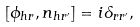<formula> <loc_0><loc_0><loc_500><loc_500>[ \phi _ { h r } , n _ { h r ^ { \prime } } ] = i \delta _ { r r ^ { \prime } } ,</formula> 